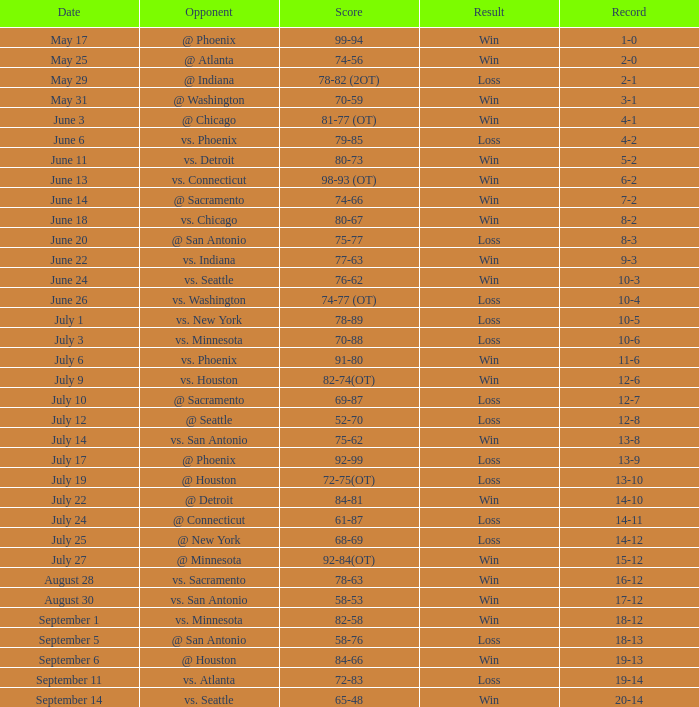What is the tally of the contest @ san antonio on june 20? 75-77. 